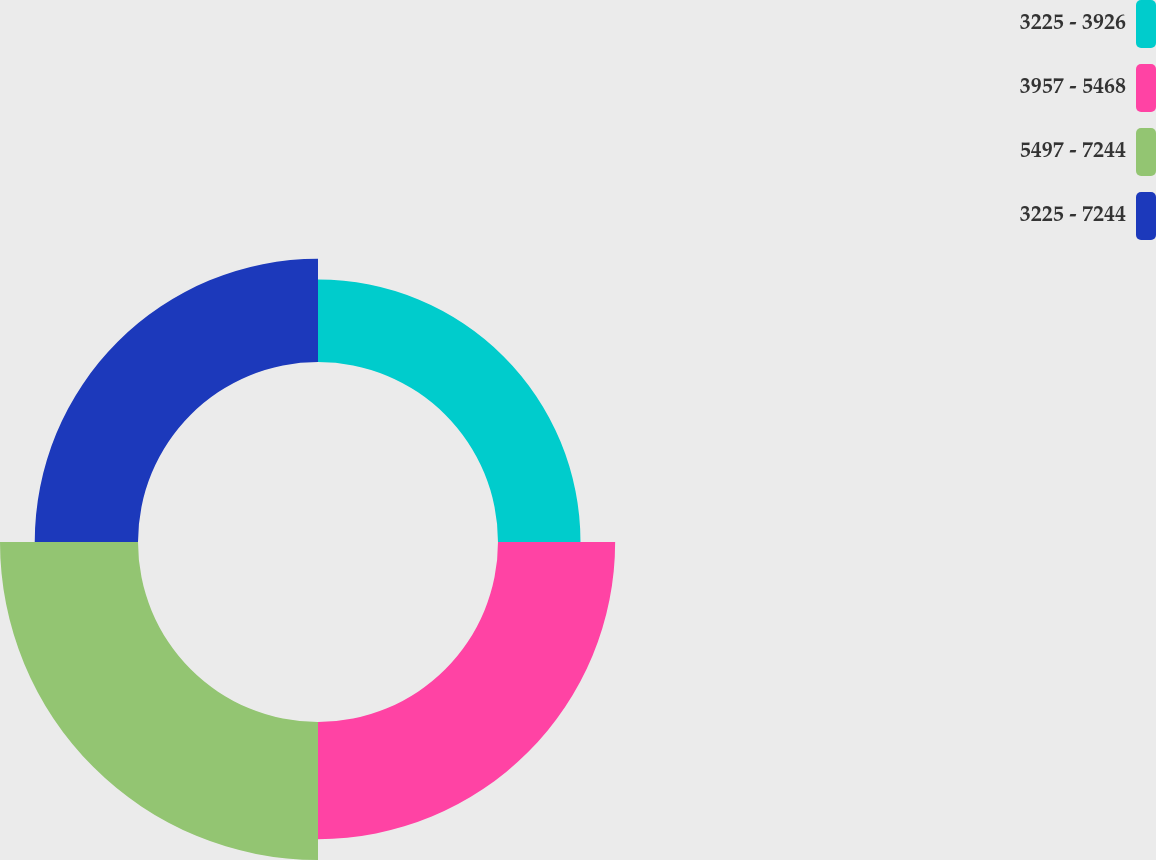Convert chart to OTSL. <chart><loc_0><loc_0><loc_500><loc_500><pie_chart><fcel>3225 - 3926<fcel>3957 - 5468<fcel>5497 - 7244<fcel>3225 - 7244<nl><fcel>18.71%<fcel>26.57%<fcel>31.3%<fcel>23.42%<nl></chart> 